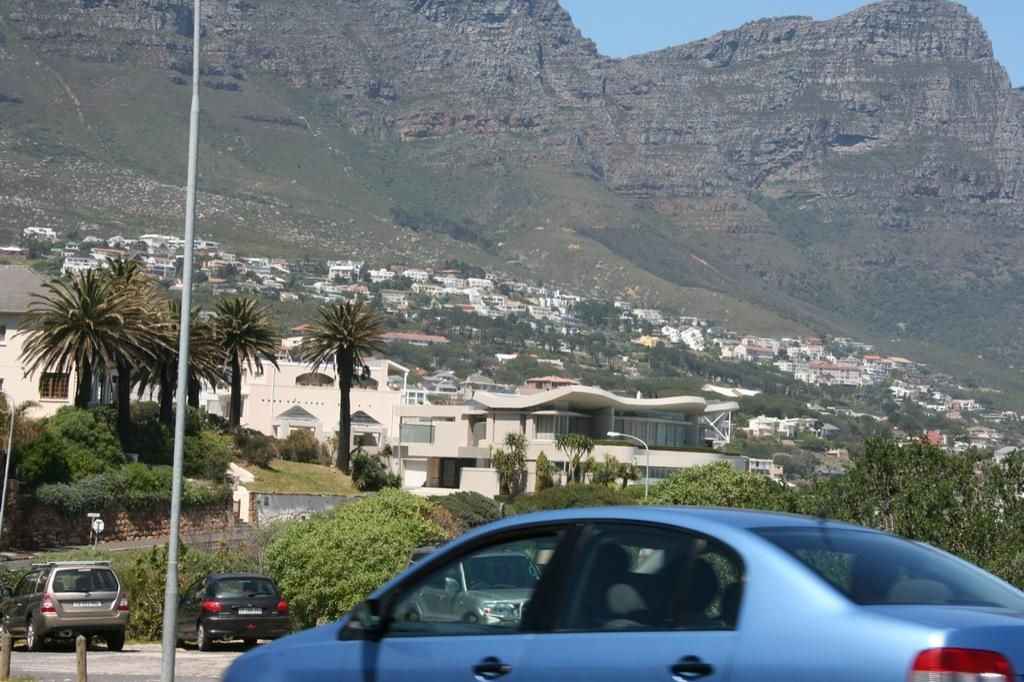What is happening on the road in the image? There are vehicles moving on the road in the image. What can be seen near the road in the image? There is a pole in the image. What type of vegetation is present in the image? There are trees in the image. What type of structures can be seen in the image? There are buildings in the image. What type of natural landform is visible in the image? There are mountains in the image. What part of the natural environment is visible in the image? The sky is visible in the image. Can you tell me how many animals are crying on the farm in the image? There is no farm or animals crying present in the image. What type of print can be seen on the vehicles in the image? There is no mention of any specific print on the vehicles in the image. 